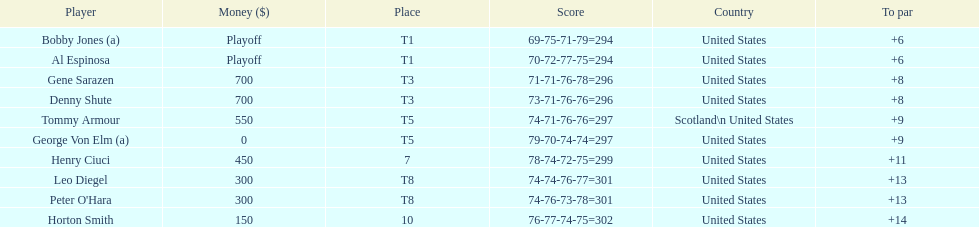Which couple of players secured a draw for the first spot? Bobby Jones (a), Al Espinosa. 